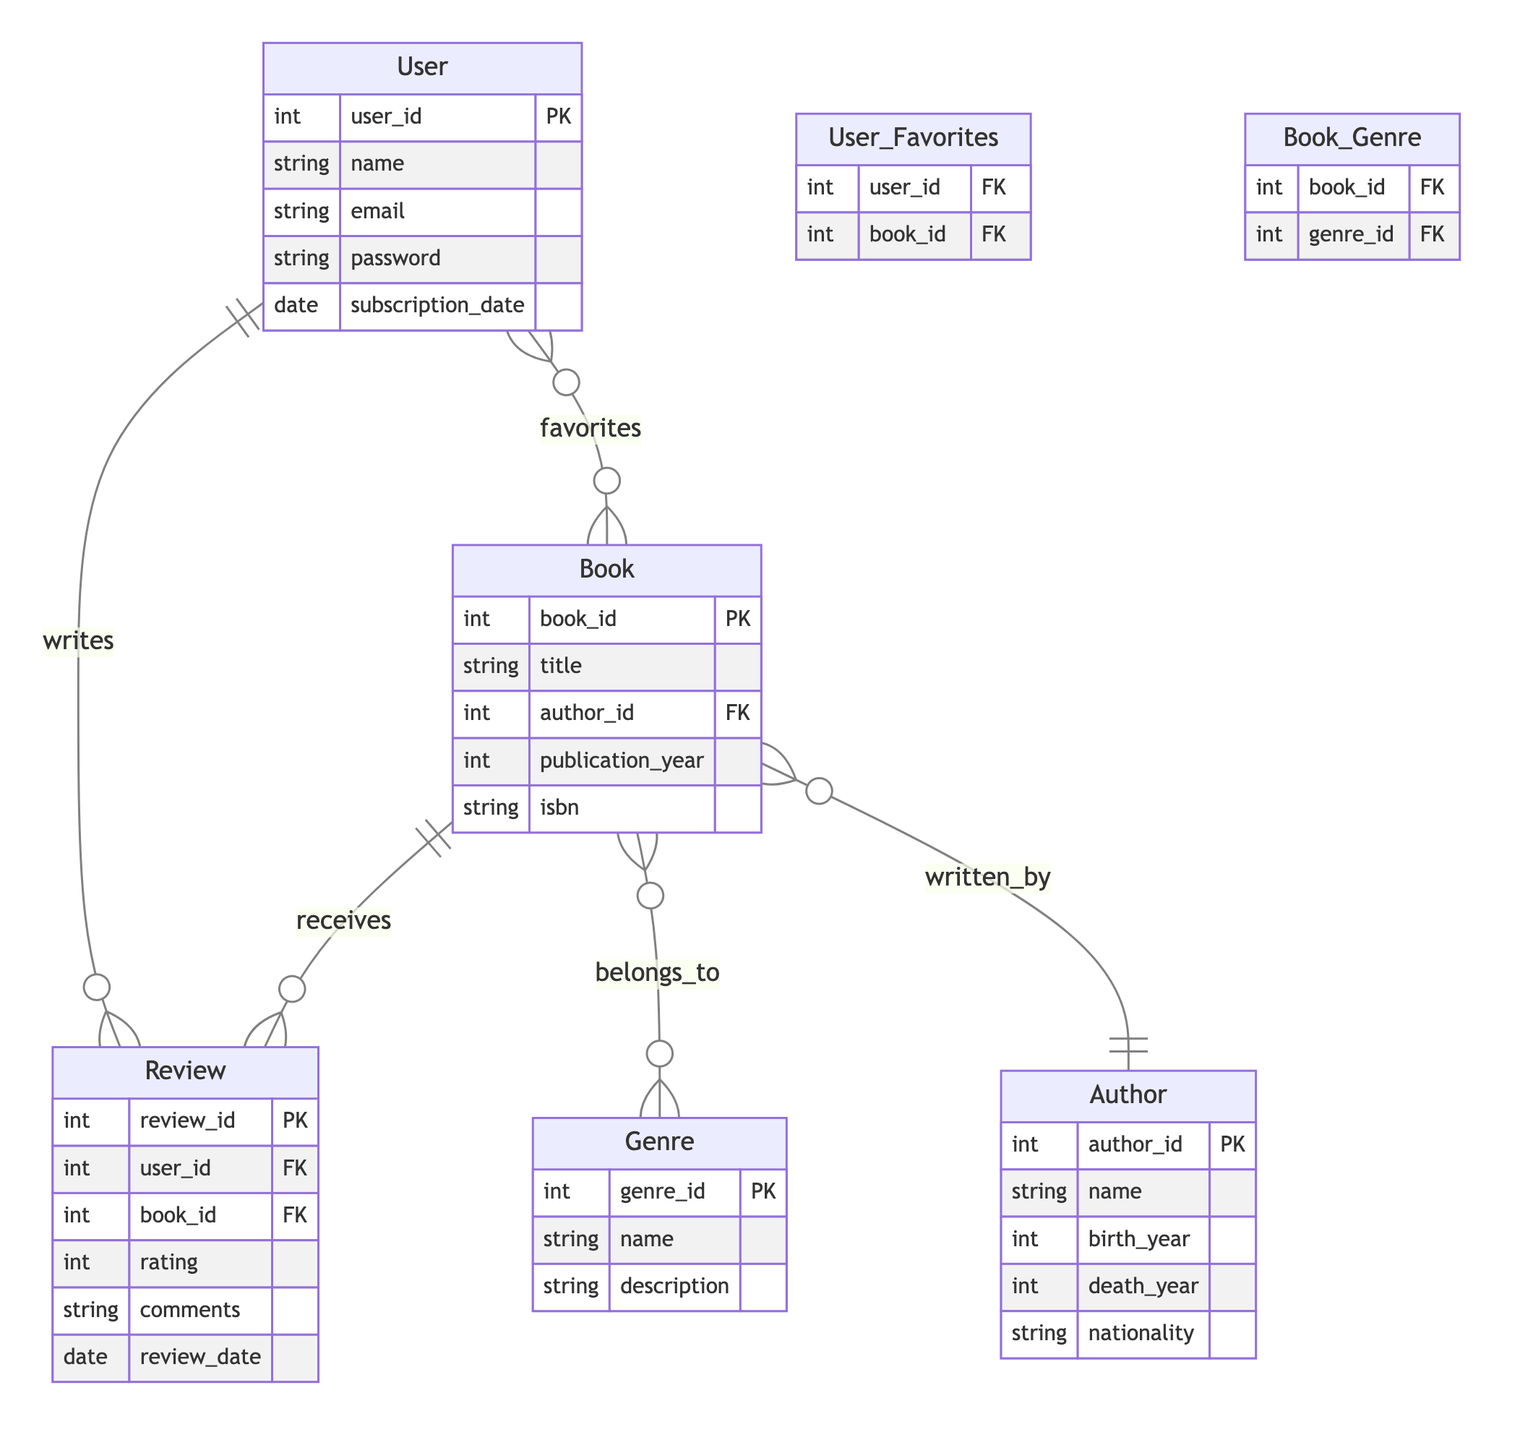What are the primary entities in the diagram? The primary entities are User, Book, Author, Genre, and Review. This can be found directly in the entities section of the diagram where each entity is listed.
Answer: User, Book, Author, Genre, Review How many attributes does the Book entity have? The Book entity includes five attributes: book_id, title, author_id, publication_year, and isbn as shown under the Book entity in the diagram.
Answer: 5 What type of relationship exists between Book and Author? The relationship between Book and Author is many-to-one, indicating that multiple books can be written by a single author. This is indicated in the relationships section of the diagram.
Answer: many-to-one How many total relationships are depicted in the diagram? There are three relationships represented in the diagram: User_Favorites, Book_Genre, and Book_Author. These can be counted in the relationships section.
Answer: 3 Which entity can a User write a Review for? A User can write a Review for a Book, as shown by the User and Book entities connected through the Review relationship, indicating users can provide feedback on books.
Answer: Book What is the relationship type between User and Book in User_Favorites? The relationship type between User and Book in User_Favorites is many-to-many, meaning that a user can favorite multiple books and a book can be favorited by multiple users. This is outlined in the relationships section.
Answer: many-to-many What foreign key is present in the Review entity? The Review entity contains two foreign keys: user_id and book_id, linking it to the User and Book entities, respectively. This is noted in the attributes of the Review entity.
Answer: user_id, book_id What data type is the author_id attribute in the Book entity? The author_id attribute in the Book entity is an integer data type as indicated in the Book entity attributes, specifying the format for each attribute.
Answer: int Which attribute connects the Review entity to the User entity? The user_id attribute connects the Review entity to the User entity as it serves as a foreign key in the Review table, representing which user made the review.
Answer: user_id 